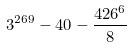Convert formula to latex. <formula><loc_0><loc_0><loc_500><loc_500>3 ^ { 2 6 9 } - 4 0 - \frac { 4 2 6 ^ { 6 } } { 8 }</formula> 